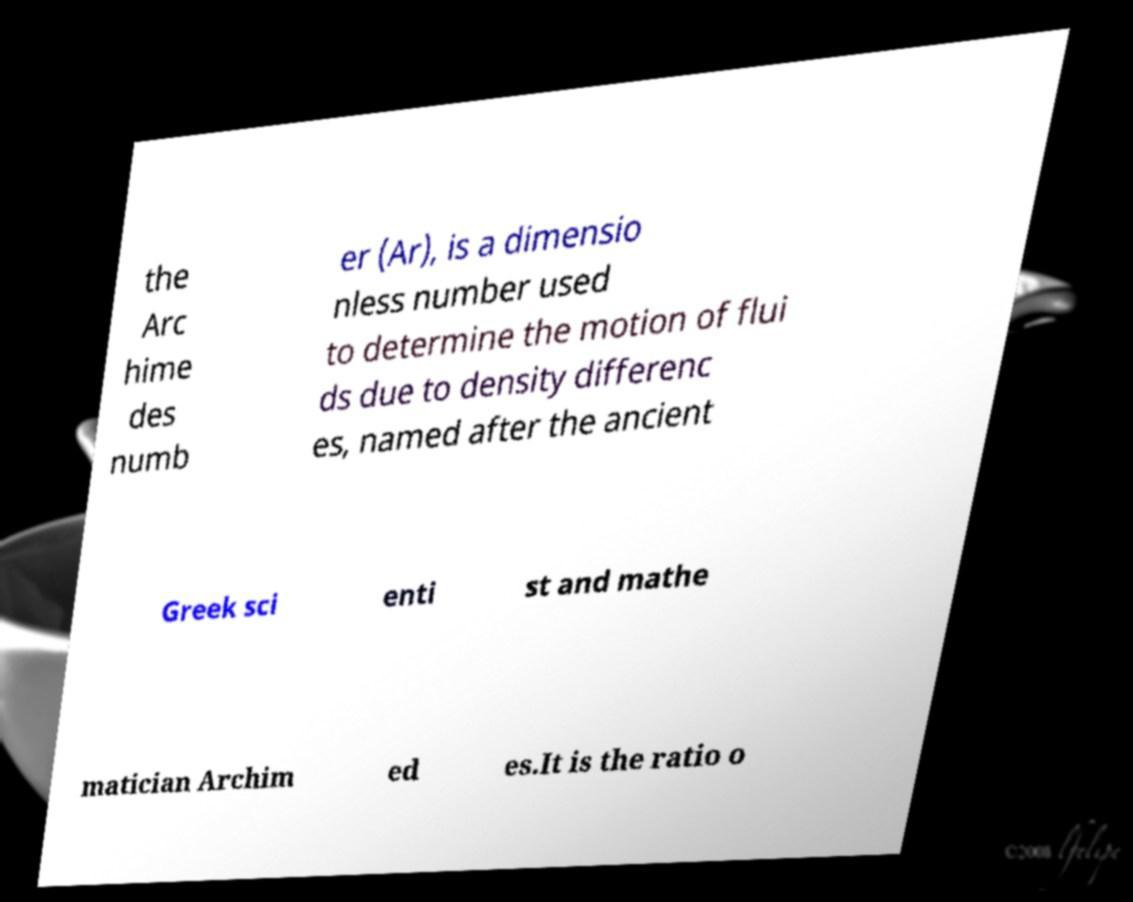What messages or text are displayed in this image? I need them in a readable, typed format. the Arc hime des numb er (Ar), is a dimensio nless number used to determine the motion of flui ds due to density differenc es, named after the ancient Greek sci enti st and mathe matician Archim ed es.It is the ratio o 